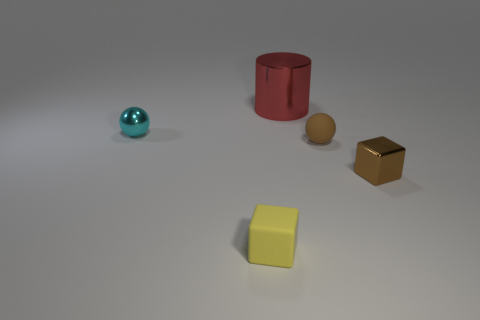Are there any tiny yellow metal objects that have the same shape as the brown rubber thing? No, there are no tiny yellow metal objects resembling the brown rubber object in shape. The objects present include a light blue sphere, a yellow cube, a golden cube, a red cylinder, and a brown sphere, each made of different materials and colors. 